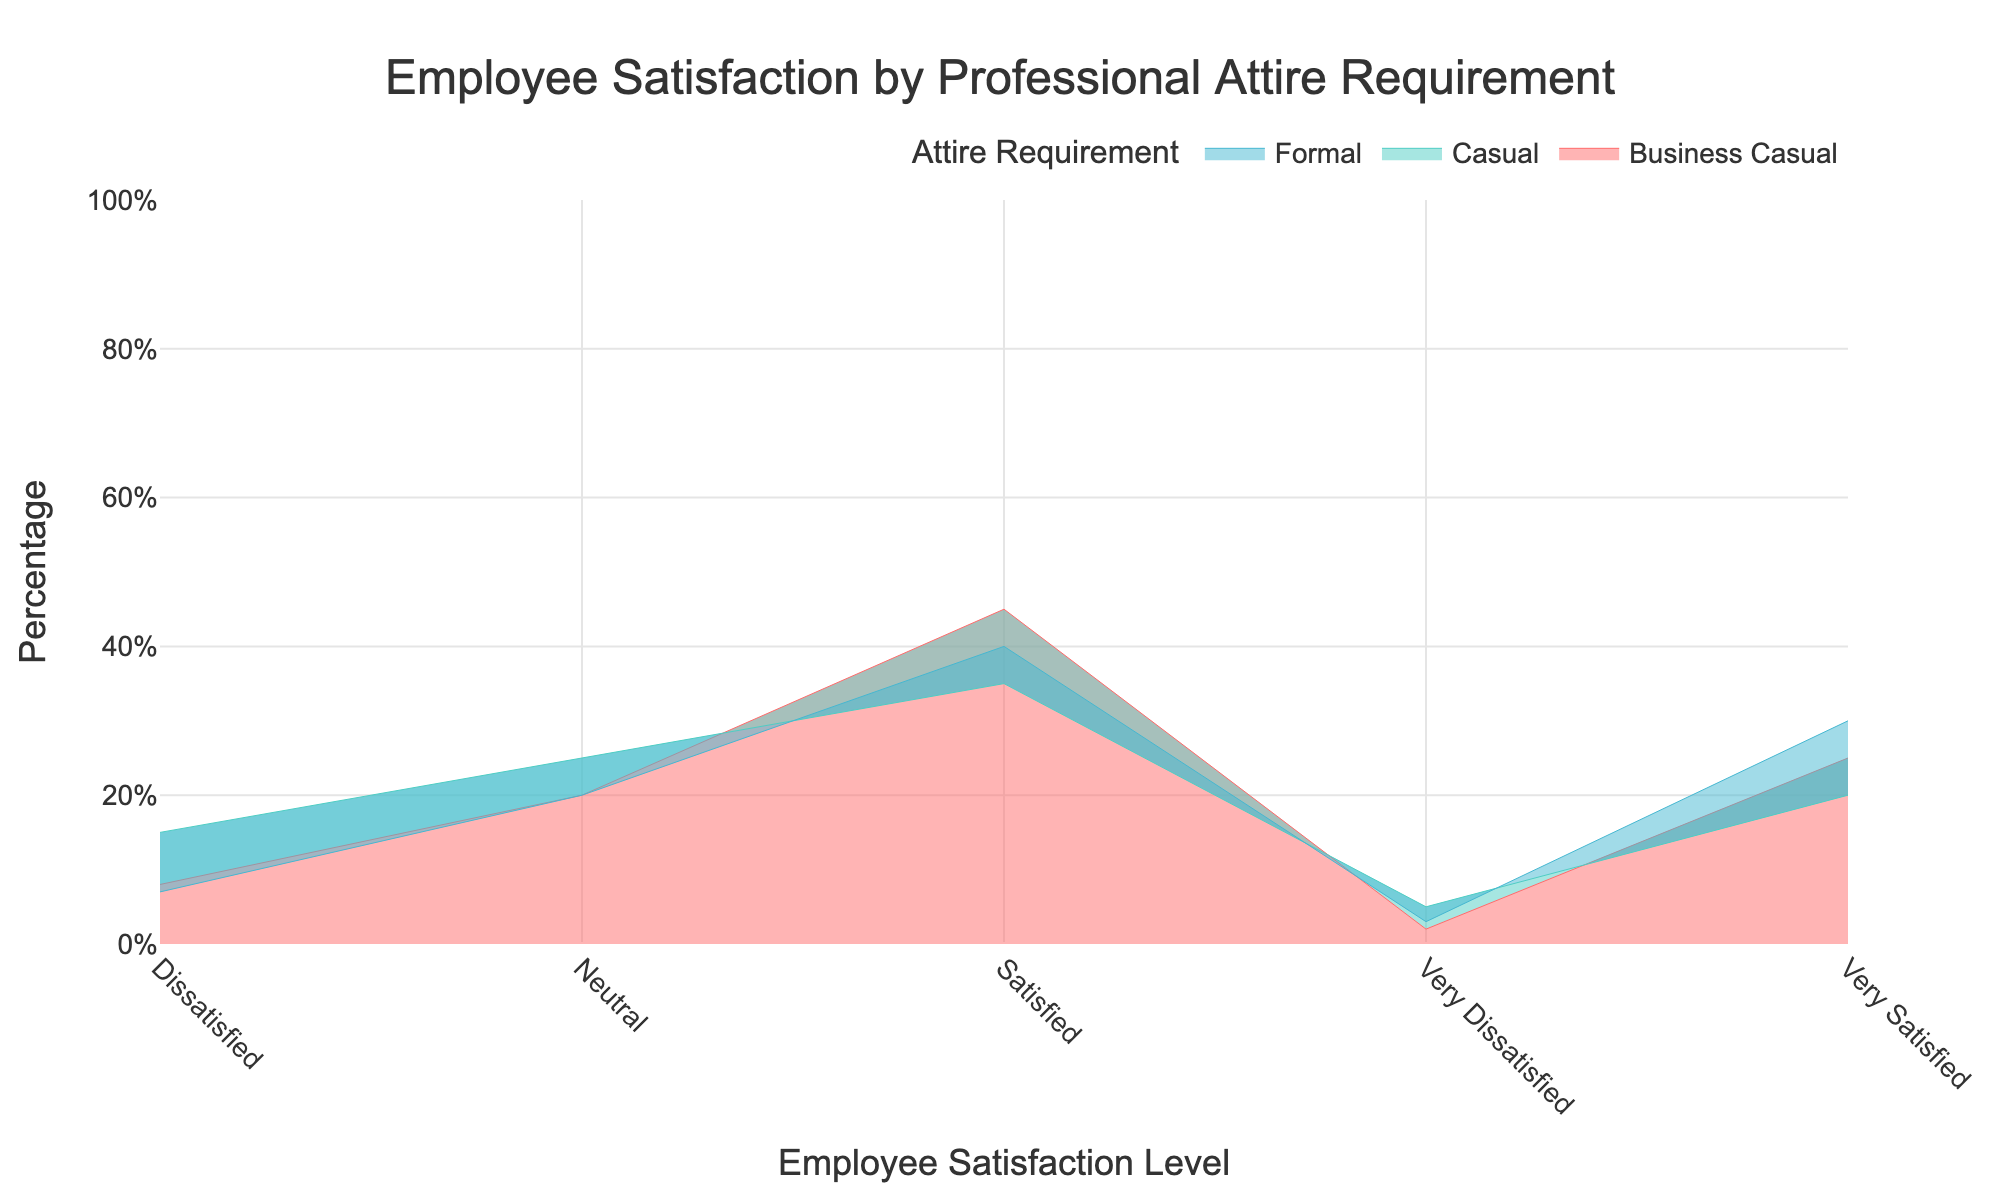What is the title of the figure? The title is usually found at the top of the chart and gives an overview of what the chart represents. The title in this case is "Employee Satisfaction by Professional Attire Requirement".
Answer: Employee Satisfaction by Professional Attire Requirement What is the percentage of employees 'Very Satisfied' with 'Formal' attire? Look for the section labeled 'Very Satisfied' on the x-axis and identify the percentage for the 'Formal' attire category. The percentage shown is 30.
Answer: 30% Which attire requirement has the highest percentage of 'Satisfied' employees? Compare the percentages of 'Satisfied' employees across the different attire requirements 'Formal', 'Business Casual', and 'Casual'. 'Business Casual' has the highest percentage at 45%.
Answer: Business Casual How does the percentage of employees who are 'Dissatisfied' with 'Casual' attire compare to 'Business Casual' attire? Find the 'Dissatisfied' category on the x-axis and compare the percentages for 'Casual' (15%) and 'Business Casual' (8%). 'Casual' has a higher percentage.
Answer: Casual has a higher percentage What is the range of percentages for 'Neutral' satisfaction across all attire requirements? Look at the 'Neutral' category and identify the percentages for all attire types: 'Formal' (20%), 'Business Casual' (20%), and 'Casual' (25%). The range is from 20% to 25%.
Answer: 20% to 25% What is the total percentage of employees 'Very Dissatisfied' across all attire requirements? Sum the percentages of 'Very Dissatisfied' employees across 'Formal' (3%), 'Business Casual' (2%), and 'Casual' (5%). The total is 3 + 2 + 5 = 10.
Answer: 10% Which attire requirement has the highest percentage of 'Very Satisfied' employees? Compare the 'Very Satisfied' percentages for all attire requirements. 'Formal' has the highest percentage at 30%.
Answer: Formal How do the percentages of 'Satisfied' employees vary among the different attire requirements? Identify the 'Satisfied' category and note the percentages for 'Formal' (40%), 'Business Casual' (45%), and 'Casual' (35%).
Answer: 40%, 45%, 35% What percentage of employees are 'Neutral' when wearing 'Formal' attire? Locate the 'Neutral' category on the x-axis and find the corresponding percentage for 'Formal' attire, which is 20%.
Answer: 20% Compare the percentages of employees who are 'Very Dissatisfied' with 'Formal' and 'Casual' attire. Find the percentages of 'Very Dissatisfied' employees for 'Formal' (3%) and 'Casual' (5%). 'Casual' has a higher percentage.
Answer: Casual has a higher percentage 